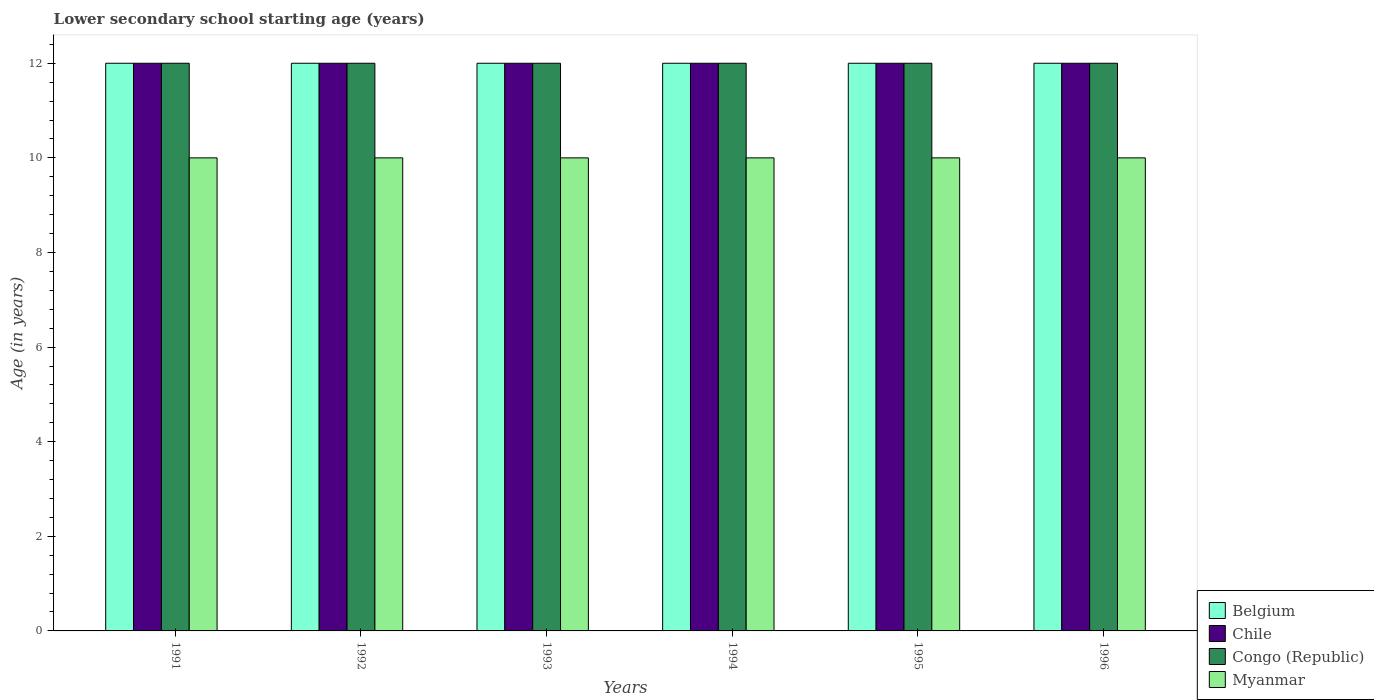How many different coloured bars are there?
Offer a very short reply. 4. How many groups of bars are there?
Make the answer very short. 6. How many bars are there on the 2nd tick from the left?
Give a very brief answer. 4. What is the lower secondary school starting age of children in Chile in 1995?
Keep it short and to the point. 12. Across all years, what is the maximum lower secondary school starting age of children in Myanmar?
Provide a short and direct response. 10. Across all years, what is the minimum lower secondary school starting age of children in Belgium?
Offer a very short reply. 12. What is the total lower secondary school starting age of children in Belgium in the graph?
Make the answer very short. 72. What is the difference between the lower secondary school starting age of children in Chile in 1995 and that in 1996?
Ensure brevity in your answer.  0. What is the average lower secondary school starting age of children in Congo (Republic) per year?
Your response must be concise. 12. What is the ratio of the lower secondary school starting age of children in Belgium in 1991 to that in 1993?
Offer a very short reply. 1. Is the lower secondary school starting age of children in Congo (Republic) in 1991 less than that in 1992?
Keep it short and to the point. No. Is the difference between the lower secondary school starting age of children in Belgium in 1995 and 1996 greater than the difference between the lower secondary school starting age of children in Congo (Republic) in 1995 and 1996?
Keep it short and to the point. No. What is the difference between the highest and the lowest lower secondary school starting age of children in Chile?
Offer a terse response. 0. Is it the case that in every year, the sum of the lower secondary school starting age of children in Myanmar and lower secondary school starting age of children in Belgium is greater than the sum of lower secondary school starting age of children in Chile and lower secondary school starting age of children in Congo (Republic)?
Give a very brief answer. No. What does the 4th bar from the left in 1996 represents?
Offer a very short reply. Myanmar. Is it the case that in every year, the sum of the lower secondary school starting age of children in Chile and lower secondary school starting age of children in Congo (Republic) is greater than the lower secondary school starting age of children in Belgium?
Your response must be concise. Yes. Are all the bars in the graph horizontal?
Keep it short and to the point. No. Are the values on the major ticks of Y-axis written in scientific E-notation?
Provide a succinct answer. No. Where does the legend appear in the graph?
Give a very brief answer. Bottom right. How are the legend labels stacked?
Your response must be concise. Vertical. What is the title of the graph?
Make the answer very short. Lower secondary school starting age (years). What is the label or title of the Y-axis?
Make the answer very short. Age (in years). What is the Age (in years) in Chile in 1991?
Make the answer very short. 12. What is the Age (in years) of Congo (Republic) in 1991?
Give a very brief answer. 12. What is the Age (in years) in Congo (Republic) in 1992?
Keep it short and to the point. 12. What is the Age (in years) in Belgium in 1993?
Ensure brevity in your answer.  12. What is the Age (in years) in Congo (Republic) in 1993?
Offer a terse response. 12. What is the Age (in years) in Chile in 1994?
Keep it short and to the point. 12. What is the Age (in years) in Myanmar in 1994?
Offer a terse response. 10. What is the Age (in years) of Belgium in 1996?
Your answer should be compact. 12. What is the Age (in years) of Chile in 1996?
Provide a succinct answer. 12. What is the Age (in years) in Congo (Republic) in 1996?
Your response must be concise. 12. What is the Age (in years) of Myanmar in 1996?
Make the answer very short. 10. Across all years, what is the maximum Age (in years) in Myanmar?
Provide a succinct answer. 10. Across all years, what is the minimum Age (in years) in Belgium?
Give a very brief answer. 12. What is the difference between the Age (in years) of Belgium in 1991 and that in 1992?
Keep it short and to the point. 0. What is the difference between the Age (in years) of Chile in 1991 and that in 1992?
Offer a terse response. 0. What is the difference between the Age (in years) of Congo (Republic) in 1991 and that in 1992?
Your answer should be compact. 0. What is the difference between the Age (in years) in Belgium in 1991 and that in 1993?
Ensure brevity in your answer.  0. What is the difference between the Age (in years) of Myanmar in 1991 and that in 1993?
Your answer should be very brief. 0. What is the difference between the Age (in years) in Belgium in 1991 and that in 1994?
Your response must be concise. 0. What is the difference between the Age (in years) of Chile in 1991 and that in 1994?
Offer a very short reply. 0. What is the difference between the Age (in years) of Belgium in 1991 and that in 1995?
Offer a very short reply. 0. What is the difference between the Age (in years) of Chile in 1991 and that in 1995?
Your answer should be very brief. 0. What is the difference between the Age (in years) in Myanmar in 1991 and that in 1995?
Keep it short and to the point. 0. What is the difference between the Age (in years) in Belgium in 1991 and that in 1996?
Keep it short and to the point. 0. What is the difference between the Age (in years) in Congo (Republic) in 1991 and that in 1996?
Provide a short and direct response. 0. What is the difference between the Age (in years) of Belgium in 1992 and that in 1993?
Your response must be concise. 0. What is the difference between the Age (in years) of Congo (Republic) in 1992 and that in 1993?
Make the answer very short. 0. What is the difference between the Age (in years) of Chile in 1992 and that in 1994?
Make the answer very short. 0. What is the difference between the Age (in years) in Belgium in 1992 and that in 1995?
Your response must be concise. 0. What is the difference between the Age (in years) of Chile in 1992 and that in 1995?
Give a very brief answer. 0. What is the difference between the Age (in years) in Congo (Republic) in 1992 and that in 1995?
Your answer should be compact. 0. What is the difference between the Age (in years) in Myanmar in 1992 and that in 1995?
Ensure brevity in your answer.  0. What is the difference between the Age (in years) of Belgium in 1992 and that in 1996?
Ensure brevity in your answer.  0. What is the difference between the Age (in years) in Myanmar in 1992 and that in 1996?
Provide a succinct answer. 0. What is the difference between the Age (in years) of Belgium in 1993 and that in 1995?
Provide a short and direct response. 0. What is the difference between the Age (in years) of Myanmar in 1993 and that in 1995?
Offer a terse response. 0. What is the difference between the Age (in years) in Belgium in 1993 and that in 1996?
Give a very brief answer. 0. What is the difference between the Age (in years) in Chile in 1993 and that in 1996?
Offer a very short reply. 0. What is the difference between the Age (in years) of Congo (Republic) in 1993 and that in 1996?
Offer a terse response. 0. What is the difference between the Age (in years) of Myanmar in 1993 and that in 1996?
Keep it short and to the point. 0. What is the difference between the Age (in years) of Congo (Republic) in 1994 and that in 1995?
Your response must be concise. 0. What is the difference between the Age (in years) of Myanmar in 1994 and that in 1995?
Provide a succinct answer. 0. What is the difference between the Age (in years) in Chile in 1994 and that in 1996?
Provide a succinct answer. 0. What is the difference between the Age (in years) in Congo (Republic) in 1994 and that in 1996?
Your answer should be very brief. 0. What is the difference between the Age (in years) of Myanmar in 1994 and that in 1996?
Make the answer very short. 0. What is the difference between the Age (in years) of Belgium in 1995 and that in 1996?
Give a very brief answer. 0. What is the difference between the Age (in years) of Chile in 1995 and that in 1996?
Ensure brevity in your answer.  0. What is the difference between the Age (in years) of Belgium in 1991 and the Age (in years) of Chile in 1992?
Keep it short and to the point. 0. What is the difference between the Age (in years) in Belgium in 1991 and the Age (in years) in Congo (Republic) in 1992?
Keep it short and to the point. 0. What is the difference between the Age (in years) in Chile in 1991 and the Age (in years) in Myanmar in 1992?
Your answer should be very brief. 2. What is the difference between the Age (in years) in Congo (Republic) in 1991 and the Age (in years) in Myanmar in 1992?
Provide a short and direct response. 2. What is the difference between the Age (in years) in Belgium in 1991 and the Age (in years) in Chile in 1993?
Your response must be concise. 0. What is the difference between the Age (in years) in Belgium in 1991 and the Age (in years) in Congo (Republic) in 1993?
Your response must be concise. 0. What is the difference between the Age (in years) in Chile in 1991 and the Age (in years) in Congo (Republic) in 1993?
Provide a succinct answer. 0. What is the difference between the Age (in years) in Chile in 1991 and the Age (in years) in Myanmar in 1993?
Offer a very short reply. 2. What is the difference between the Age (in years) of Congo (Republic) in 1991 and the Age (in years) of Myanmar in 1993?
Keep it short and to the point. 2. What is the difference between the Age (in years) in Belgium in 1991 and the Age (in years) in Myanmar in 1994?
Keep it short and to the point. 2. What is the difference between the Age (in years) of Chile in 1991 and the Age (in years) of Congo (Republic) in 1994?
Keep it short and to the point. 0. What is the difference between the Age (in years) of Chile in 1991 and the Age (in years) of Myanmar in 1994?
Provide a succinct answer. 2. What is the difference between the Age (in years) of Congo (Republic) in 1991 and the Age (in years) of Myanmar in 1994?
Your response must be concise. 2. What is the difference between the Age (in years) in Belgium in 1991 and the Age (in years) in Myanmar in 1995?
Offer a terse response. 2. What is the difference between the Age (in years) in Chile in 1991 and the Age (in years) in Congo (Republic) in 1995?
Your response must be concise. 0. What is the difference between the Age (in years) in Chile in 1991 and the Age (in years) in Myanmar in 1996?
Your response must be concise. 2. What is the difference between the Age (in years) in Belgium in 1992 and the Age (in years) in Congo (Republic) in 1993?
Your answer should be very brief. 0. What is the difference between the Age (in years) in Chile in 1992 and the Age (in years) in Congo (Republic) in 1993?
Ensure brevity in your answer.  0. What is the difference between the Age (in years) in Congo (Republic) in 1992 and the Age (in years) in Myanmar in 1994?
Ensure brevity in your answer.  2. What is the difference between the Age (in years) of Belgium in 1992 and the Age (in years) of Chile in 1995?
Ensure brevity in your answer.  0. What is the difference between the Age (in years) of Belgium in 1992 and the Age (in years) of Congo (Republic) in 1995?
Make the answer very short. 0. What is the difference between the Age (in years) in Belgium in 1992 and the Age (in years) in Myanmar in 1995?
Make the answer very short. 2. What is the difference between the Age (in years) in Congo (Republic) in 1992 and the Age (in years) in Myanmar in 1995?
Offer a very short reply. 2. What is the difference between the Age (in years) of Belgium in 1992 and the Age (in years) of Chile in 1996?
Provide a short and direct response. 0. What is the difference between the Age (in years) in Chile in 1992 and the Age (in years) in Congo (Republic) in 1996?
Provide a succinct answer. 0. What is the difference between the Age (in years) in Congo (Republic) in 1992 and the Age (in years) in Myanmar in 1996?
Your answer should be very brief. 2. What is the difference between the Age (in years) of Belgium in 1993 and the Age (in years) of Chile in 1994?
Keep it short and to the point. 0. What is the difference between the Age (in years) of Belgium in 1993 and the Age (in years) of Myanmar in 1994?
Give a very brief answer. 2. What is the difference between the Age (in years) of Chile in 1993 and the Age (in years) of Myanmar in 1994?
Keep it short and to the point. 2. What is the difference between the Age (in years) in Belgium in 1993 and the Age (in years) in Chile in 1995?
Provide a succinct answer. 0. What is the difference between the Age (in years) in Belgium in 1993 and the Age (in years) in Congo (Republic) in 1995?
Provide a succinct answer. 0. What is the difference between the Age (in years) in Belgium in 1993 and the Age (in years) in Myanmar in 1995?
Keep it short and to the point. 2. What is the difference between the Age (in years) in Chile in 1993 and the Age (in years) in Congo (Republic) in 1995?
Offer a terse response. 0. What is the difference between the Age (in years) of Chile in 1993 and the Age (in years) of Myanmar in 1995?
Ensure brevity in your answer.  2. What is the difference between the Age (in years) in Congo (Republic) in 1993 and the Age (in years) in Myanmar in 1995?
Provide a short and direct response. 2. What is the difference between the Age (in years) in Chile in 1993 and the Age (in years) in Congo (Republic) in 1996?
Give a very brief answer. 0. What is the difference between the Age (in years) of Chile in 1993 and the Age (in years) of Myanmar in 1996?
Ensure brevity in your answer.  2. What is the difference between the Age (in years) in Congo (Republic) in 1993 and the Age (in years) in Myanmar in 1996?
Offer a terse response. 2. What is the difference between the Age (in years) in Belgium in 1994 and the Age (in years) in Myanmar in 1995?
Provide a short and direct response. 2. What is the difference between the Age (in years) in Chile in 1994 and the Age (in years) in Myanmar in 1995?
Provide a succinct answer. 2. What is the difference between the Age (in years) of Belgium in 1994 and the Age (in years) of Congo (Republic) in 1996?
Provide a short and direct response. 0. What is the difference between the Age (in years) in Belgium in 1994 and the Age (in years) in Myanmar in 1996?
Your answer should be compact. 2. What is the difference between the Age (in years) in Chile in 1994 and the Age (in years) in Congo (Republic) in 1996?
Offer a very short reply. 0. What is the difference between the Age (in years) in Belgium in 1995 and the Age (in years) in Chile in 1996?
Offer a very short reply. 0. What is the difference between the Age (in years) in Belgium in 1995 and the Age (in years) in Congo (Republic) in 1996?
Give a very brief answer. 0. What is the difference between the Age (in years) of Belgium in 1995 and the Age (in years) of Myanmar in 1996?
Offer a terse response. 2. What is the average Age (in years) in Belgium per year?
Keep it short and to the point. 12. In the year 1991, what is the difference between the Age (in years) in Belgium and Age (in years) in Chile?
Make the answer very short. 0. In the year 1991, what is the difference between the Age (in years) in Belgium and Age (in years) in Congo (Republic)?
Your response must be concise. 0. In the year 1991, what is the difference between the Age (in years) of Belgium and Age (in years) of Myanmar?
Make the answer very short. 2. In the year 1991, what is the difference between the Age (in years) of Chile and Age (in years) of Myanmar?
Your response must be concise. 2. In the year 1992, what is the difference between the Age (in years) in Belgium and Age (in years) in Chile?
Provide a short and direct response. 0. In the year 1992, what is the difference between the Age (in years) of Chile and Age (in years) of Congo (Republic)?
Provide a short and direct response. 0. In the year 1992, what is the difference between the Age (in years) in Chile and Age (in years) in Myanmar?
Provide a short and direct response. 2. In the year 1993, what is the difference between the Age (in years) of Belgium and Age (in years) of Congo (Republic)?
Give a very brief answer. 0. In the year 1993, what is the difference between the Age (in years) of Belgium and Age (in years) of Myanmar?
Provide a succinct answer. 2. In the year 1993, what is the difference between the Age (in years) of Chile and Age (in years) of Myanmar?
Keep it short and to the point. 2. In the year 1994, what is the difference between the Age (in years) in Belgium and Age (in years) in Congo (Republic)?
Give a very brief answer. 0. In the year 1994, what is the difference between the Age (in years) in Belgium and Age (in years) in Myanmar?
Your answer should be compact. 2. In the year 1994, what is the difference between the Age (in years) of Chile and Age (in years) of Myanmar?
Keep it short and to the point. 2. In the year 1994, what is the difference between the Age (in years) of Congo (Republic) and Age (in years) of Myanmar?
Provide a short and direct response. 2. In the year 1995, what is the difference between the Age (in years) of Belgium and Age (in years) of Congo (Republic)?
Offer a terse response. 0. In the year 1995, what is the difference between the Age (in years) in Chile and Age (in years) in Myanmar?
Ensure brevity in your answer.  2. In the year 1996, what is the difference between the Age (in years) of Belgium and Age (in years) of Chile?
Your answer should be very brief. 0. In the year 1996, what is the difference between the Age (in years) in Belgium and Age (in years) in Myanmar?
Your answer should be very brief. 2. In the year 1996, what is the difference between the Age (in years) of Chile and Age (in years) of Congo (Republic)?
Provide a succinct answer. 0. What is the ratio of the Age (in years) in Myanmar in 1991 to that in 1992?
Provide a short and direct response. 1. What is the ratio of the Age (in years) of Belgium in 1991 to that in 1993?
Ensure brevity in your answer.  1. What is the ratio of the Age (in years) of Congo (Republic) in 1991 to that in 1993?
Give a very brief answer. 1. What is the ratio of the Age (in years) in Myanmar in 1991 to that in 1993?
Provide a succinct answer. 1. What is the ratio of the Age (in years) of Congo (Republic) in 1991 to that in 1994?
Make the answer very short. 1. What is the ratio of the Age (in years) in Myanmar in 1991 to that in 1994?
Provide a short and direct response. 1. What is the ratio of the Age (in years) of Chile in 1991 to that in 1995?
Your response must be concise. 1. What is the ratio of the Age (in years) in Congo (Republic) in 1991 to that in 1995?
Your answer should be compact. 1. What is the ratio of the Age (in years) of Myanmar in 1991 to that in 1995?
Provide a short and direct response. 1. What is the ratio of the Age (in years) of Congo (Republic) in 1991 to that in 1996?
Keep it short and to the point. 1. What is the ratio of the Age (in years) in Belgium in 1992 to that in 1993?
Provide a succinct answer. 1. What is the ratio of the Age (in years) of Chile in 1992 to that in 1993?
Your answer should be very brief. 1. What is the ratio of the Age (in years) of Myanmar in 1992 to that in 1993?
Offer a terse response. 1. What is the ratio of the Age (in years) of Belgium in 1992 to that in 1994?
Ensure brevity in your answer.  1. What is the ratio of the Age (in years) of Chile in 1992 to that in 1994?
Provide a succinct answer. 1. What is the ratio of the Age (in years) of Congo (Republic) in 1992 to that in 1994?
Your response must be concise. 1. What is the ratio of the Age (in years) in Belgium in 1992 to that in 1995?
Your answer should be very brief. 1. What is the ratio of the Age (in years) of Chile in 1992 to that in 1995?
Your response must be concise. 1. What is the ratio of the Age (in years) in Congo (Republic) in 1992 to that in 1995?
Ensure brevity in your answer.  1. What is the ratio of the Age (in years) of Chile in 1992 to that in 1996?
Offer a very short reply. 1. What is the ratio of the Age (in years) in Congo (Republic) in 1992 to that in 1996?
Ensure brevity in your answer.  1. What is the ratio of the Age (in years) in Belgium in 1993 to that in 1994?
Keep it short and to the point. 1. What is the ratio of the Age (in years) of Congo (Republic) in 1993 to that in 1994?
Your answer should be very brief. 1. What is the ratio of the Age (in years) in Myanmar in 1993 to that in 1994?
Provide a short and direct response. 1. What is the ratio of the Age (in years) of Belgium in 1993 to that in 1995?
Provide a succinct answer. 1. What is the ratio of the Age (in years) of Congo (Republic) in 1993 to that in 1995?
Your answer should be compact. 1. What is the ratio of the Age (in years) of Chile in 1993 to that in 1996?
Provide a succinct answer. 1. What is the ratio of the Age (in years) of Chile in 1994 to that in 1995?
Offer a terse response. 1. What is the ratio of the Age (in years) in Congo (Republic) in 1994 to that in 1995?
Give a very brief answer. 1. What is the ratio of the Age (in years) of Chile in 1994 to that in 1996?
Offer a terse response. 1. What is the ratio of the Age (in years) in Congo (Republic) in 1994 to that in 1996?
Provide a short and direct response. 1. What is the ratio of the Age (in years) in Chile in 1995 to that in 1996?
Make the answer very short. 1. What is the ratio of the Age (in years) of Congo (Republic) in 1995 to that in 1996?
Your response must be concise. 1. What is the difference between the highest and the second highest Age (in years) in Chile?
Your response must be concise. 0. What is the difference between the highest and the second highest Age (in years) of Congo (Republic)?
Ensure brevity in your answer.  0. What is the difference between the highest and the second highest Age (in years) of Myanmar?
Make the answer very short. 0. What is the difference between the highest and the lowest Age (in years) in Belgium?
Provide a short and direct response. 0. What is the difference between the highest and the lowest Age (in years) of Congo (Republic)?
Offer a very short reply. 0. What is the difference between the highest and the lowest Age (in years) of Myanmar?
Provide a succinct answer. 0. 